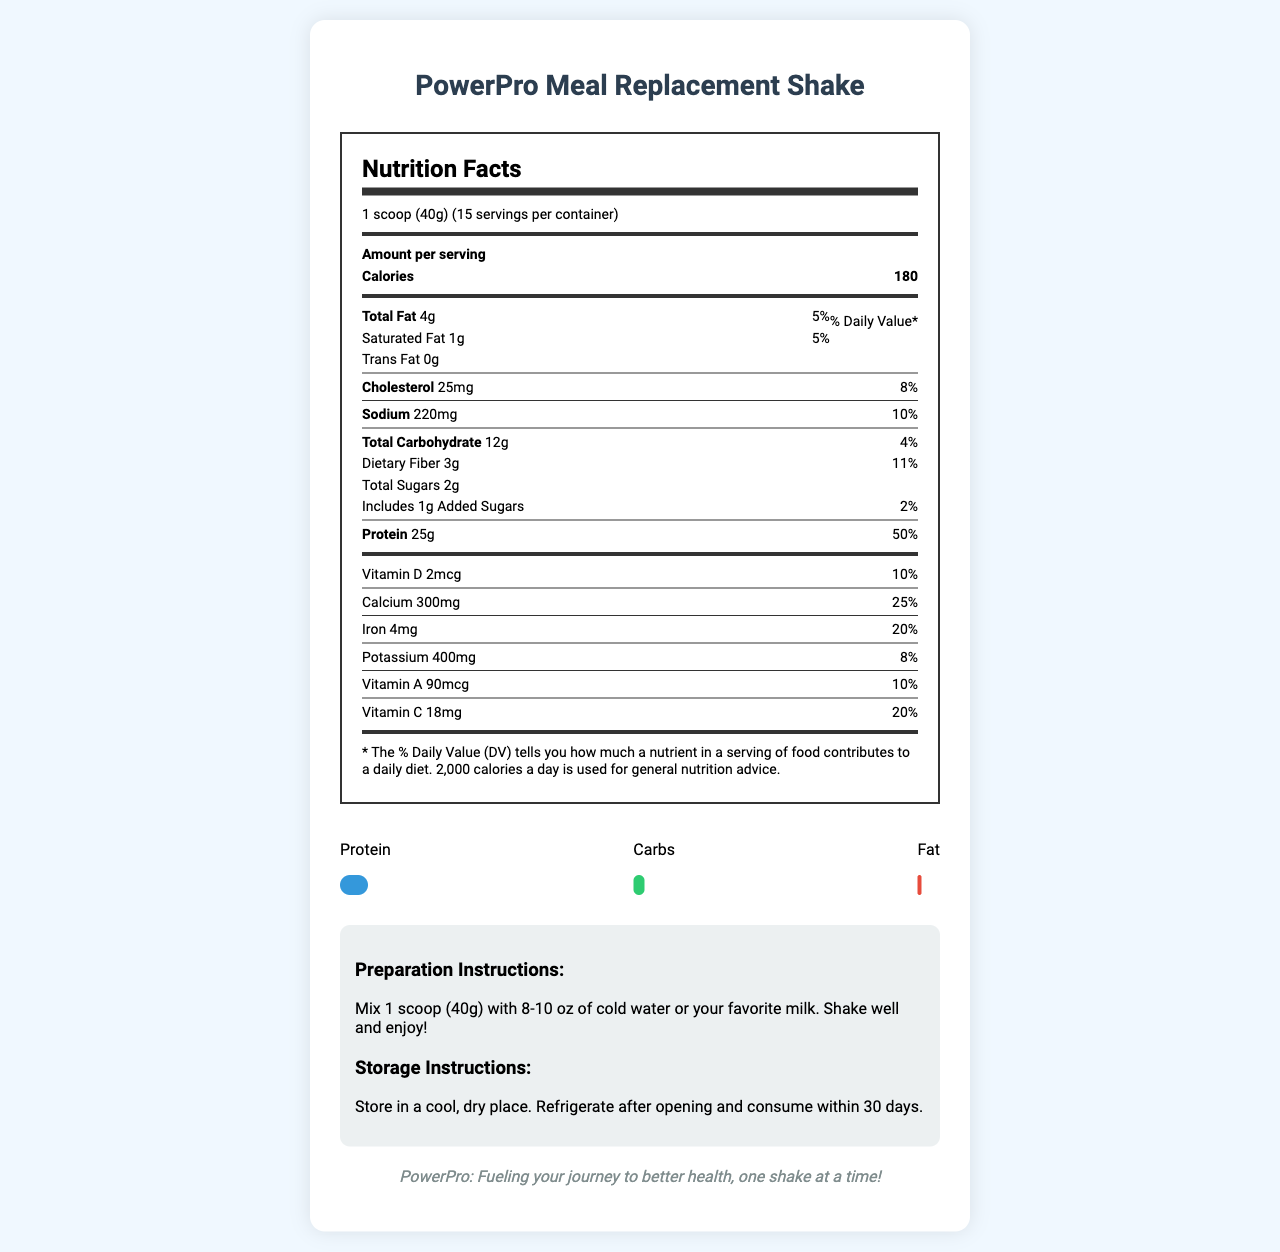what is the serving size of the PowerPro Meal Replacement Shake? The serving size is explicitly mentioned in the document as "1 scoop (40g)".
Answer: 1 scoop (40g) how many servings are there per container? The document states that there are 15 servings per container.
Answer: 15 how many calories are there per serving? The document specifies that there are 180 calories per serving.
Answer: 180 what is the amount of protein per serving? The document lists the amount of protein per serving as 25g.
Answer: 25g what percentage of the daily value of vitamin C does each serving provide? The document indicates that each serving provides 20% of the daily value for vitamin C.
Answer: 20% Which of the following statements is true? A. The shake contains added sugars. B. The shake has no dietary fiber. C. The shake is sodium-free. The document states that the shake includes 1g of added sugars, has 3g of dietary fiber, and 220mg of sodium, making A the correct option.
Answer: A how much saturated fat is in each serving of the shake? The amount of saturated fat per serving is listed in the document as 1g.
Answer: 1g what type of protein sources are included in the ingredients? A. Whey Protein Isolate B. Pea Protein C. Brown Rice Protein D. All of the above The document lists "Whey Protein Isolate", "Pea Protein", and "Brown Rice Protein" among the ingredients, making "All of the above" correct.
Answer: D Is the shake suitable for someone with a milk allergy? The document mentions that the product contains milk, making it unsuitable for someone with a milk allergy.
Answer: No can you determine if the PowerPro Meal Replacement Shake contains soy? The document states that it is produced in a facility that also processes soy, but it does not state whether soy is an ingredient in the shake itself.
Answer: Not enough information from which food group is the highest macronutrient percentage derived? The macronutrient percentage chart shows that protein has the highest percentage at 55%.
Answer: Protein summarize the main idea of this document. The document covers various nutritional aspects of the product, preparation and storage instructions, allergen warnings, and highlights its high protein content through a visual chart.
Answer: The document provides comprehensive nutritional information for the PowerPro Meal Replacement Shake, including serving size, calories, macronutrients, vitamins, and minerals. It details preparation, storage instructions, and allergen information, emphasizing its high protein content. what is the total amount of carbohydrates per serving? The document lists the total amount of carbohydrates per serving as 12g.
Answer: 12g will the shake provide more calcium or iron per serving based on the daily value percentage? The daily value percentage for calcium is 25%, while for iron it is 20%, indicating that the shake provides a higher daily value percentage of calcium.
Answer: Calcium what allergens are mentioned in the allergen information? The document's allergen information states that the shake contains milk and is produced in a facility that also processes soy, tree nuts, and eggs.
Answer: Milk, soy, tree nuts, eggs 